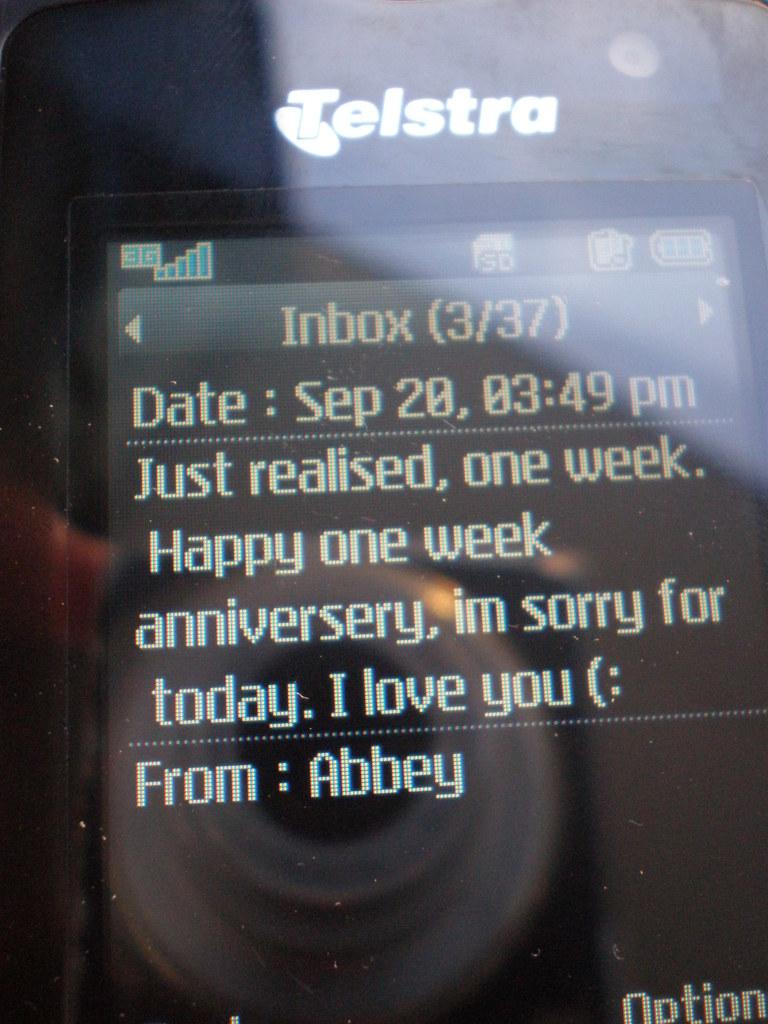<image>
Write a terse but informative summary of the picture. A text message being displayed on a Telstra cellphone. 